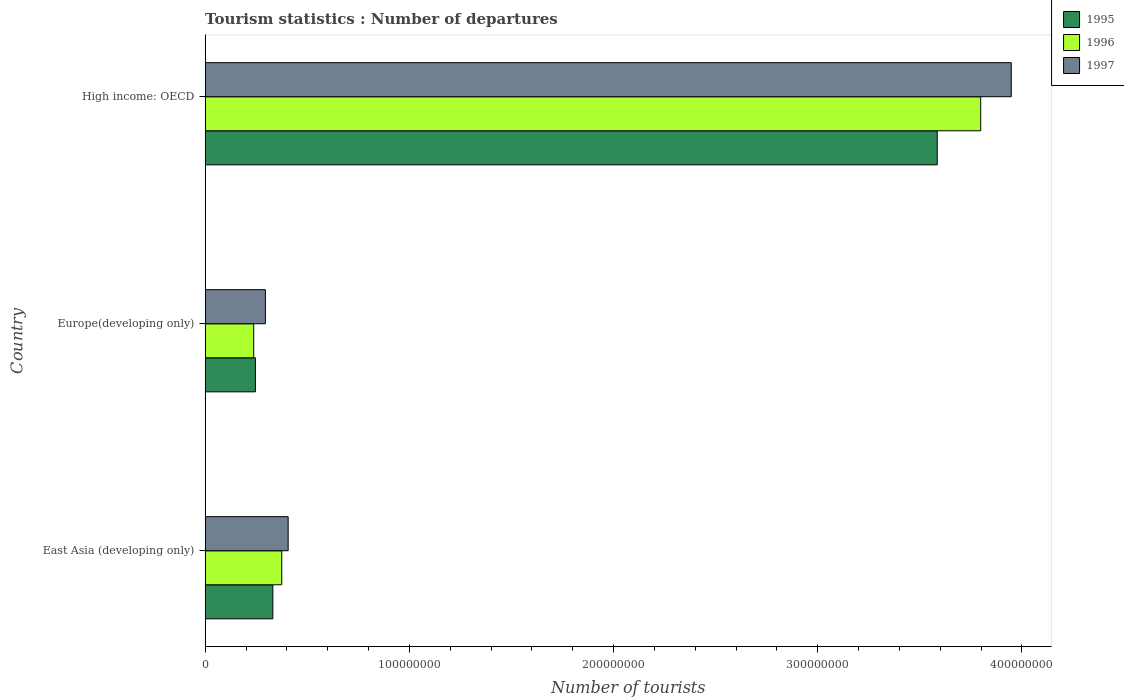How many different coloured bars are there?
Your answer should be compact. 3. Are the number of bars per tick equal to the number of legend labels?
Your answer should be compact. Yes. Are the number of bars on each tick of the Y-axis equal?
Provide a succinct answer. Yes. How many bars are there on the 1st tick from the bottom?
Provide a succinct answer. 3. What is the label of the 2nd group of bars from the top?
Your answer should be very brief. Europe(developing only). What is the number of tourist departures in 1997 in Europe(developing only)?
Your answer should be compact. 2.95e+07. Across all countries, what is the maximum number of tourist departures in 1995?
Make the answer very short. 3.58e+08. Across all countries, what is the minimum number of tourist departures in 1996?
Make the answer very short. 2.38e+07. In which country was the number of tourist departures in 1995 maximum?
Offer a very short reply. High income: OECD. In which country was the number of tourist departures in 1996 minimum?
Offer a very short reply. Europe(developing only). What is the total number of tourist departures in 1997 in the graph?
Provide a succinct answer. 4.65e+08. What is the difference between the number of tourist departures in 1995 in East Asia (developing only) and that in Europe(developing only)?
Provide a succinct answer. 8.52e+06. What is the difference between the number of tourist departures in 1996 in Europe(developing only) and the number of tourist departures in 1997 in East Asia (developing only)?
Keep it short and to the point. -1.69e+07. What is the average number of tourist departures in 1997 per country?
Make the answer very short. 1.55e+08. What is the difference between the number of tourist departures in 1995 and number of tourist departures in 1997 in East Asia (developing only)?
Keep it short and to the point. -7.50e+06. What is the ratio of the number of tourist departures in 1996 in East Asia (developing only) to that in High income: OECD?
Your answer should be compact. 0.1. Is the number of tourist departures in 1995 in Europe(developing only) less than that in High income: OECD?
Your answer should be compact. Yes. Is the difference between the number of tourist departures in 1995 in East Asia (developing only) and Europe(developing only) greater than the difference between the number of tourist departures in 1997 in East Asia (developing only) and Europe(developing only)?
Your answer should be very brief. No. What is the difference between the highest and the second highest number of tourist departures in 1996?
Your answer should be compact. 3.42e+08. What is the difference between the highest and the lowest number of tourist departures in 1997?
Keep it short and to the point. 3.65e+08. In how many countries, is the number of tourist departures in 1996 greater than the average number of tourist departures in 1996 taken over all countries?
Provide a short and direct response. 1. Is the sum of the number of tourist departures in 1995 in East Asia (developing only) and Europe(developing only) greater than the maximum number of tourist departures in 1997 across all countries?
Provide a short and direct response. No. What does the 1st bar from the top in East Asia (developing only) represents?
Keep it short and to the point. 1997. Is it the case that in every country, the sum of the number of tourist departures in 1996 and number of tourist departures in 1997 is greater than the number of tourist departures in 1995?
Give a very brief answer. Yes. How many bars are there?
Your answer should be very brief. 9. How many countries are there in the graph?
Keep it short and to the point. 3. Are the values on the major ticks of X-axis written in scientific E-notation?
Your response must be concise. No. Does the graph contain grids?
Keep it short and to the point. No. Where does the legend appear in the graph?
Your response must be concise. Top right. What is the title of the graph?
Provide a succinct answer. Tourism statistics : Number of departures. What is the label or title of the X-axis?
Provide a short and direct response. Number of tourists. What is the label or title of the Y-axis?
Your answer should be very brief. Country. What is the Number of tourists of 1995 in East Asia (developing only)?
Your response must be concise. 3.31e+07. What is the Number of tourists in 1996 in East Asia (developing only)?
Provide a succinct answer. 3.75e+07. What is the Number of tourists in 1997 in East Asia (developing only)?
Offer a terse response. 4.06e+07. What is the Number of tourists of 1995 in Europe(developing only)?
Your response must be concise. 2.46e+07. What is the Number of tourists in 1996 in Europe(developing only)?
Your answer should be very brief. 2.38e+07. What is the Number of tourists of 1997 in Europe(developing only)?
Provide a succinct answer. 2.95e+07. What is the Number of tourists of 1995 in High income: OECD?
Your response must be concise. 3.58e+08. What is the Number of tourists of 1996 in High income: OECD?
Your response must be concise. 3.80e+08. What is the Number of tourists in 1997 in High income: OECD?
Your response must be concise. 3.95e+08. Across all countries, what is the maximum Number of tourists of 1995?
Provide a short and direct response. 3.58e+08. Across all countries, what is the maximum Number of tourists of 1996?
Make the answer very short. 3.80e+08. Across all countries, what is the maximum Number of tourists in 1997?
Provide a succinct answer. 3.95e+08. Across all countries, what is the minimum Number of tourists of 1995?
Offer a terse response. 2.46e+07. Across all countries, what is the minimum Number of tourists in 1996?
Provide a succinct answer. 2.38e+07. Across all countries, what is the minimum Number of tourists in 1997?
Your response must be concise. 2.95e+07. What is the total Number of tourists of 1995 in the graph?
Make the answer very short. 4.16e+08. What is the total Number of tourists in 1996 in the graph?
Offer a terse response. 4.41e+08. What is the total Number of tourists in 1997 in the graph?
Offer a terse response. 4.65e+08. What is the difference between the Number of tourists in 1995 in East Asia (developing only) and that in Europe(developing only)?
Your answer should be very brief. 8.52e+06. What is the difference between the Number of tourists in 1996 in East Asia (developing only) and that in Europe(developing only)?
Make the answer very short. 1.37e+07. What is the difference between the Number of tourists in 1997 in East Asia (developing only) and that in Europe(developing only)?
Your answer should be very brief. 1.11e+07. What is the difference between the Number of tourists in 1995 in East Asia (developing only) and that in High income: OECD?
Offer a terse response. -3.25e+08. What is the difference between the Number of tourists in 1996 in East Asia (developing only) and that in High income: OECD?
Offer a very short reply. -3.42e+08. What is the difference between the Number of tourists of 1997 in East Asia (developing only) and that in High income: OECD?
Your answer should be compact. -3.54e+08. What is the difference between the Number of tourists in 1995 in Europe(developing only) and that in High income: OECD?
Your answer should be compact. -3.34e+08. What is the difference between the Number of tourists in 1996 in Europe(developing only) and that in High income: OECD?
Your response must be concise. -3.56e+08. What is the difference between the Number of tourists of 1997 in Europe(developing only) and that in High income: OECD?
Your response must be concise. -3.65e+08. What is the difference between the Number of tourists of 1995 in East Asia (developing only) and the Number of tourists of 1996 in Europe(developing only)?
Offer a very short reply. 9.37e+06. What is the difference between the Number of tourists of 1995 in East Asia (developing only) and the Number of tourists of 1997 in Europe(developing only)?
Your answer should be compact. 3.65e+06. What is the difference between the Number of tourists of 1996 in East Asia (developing only) and the Number of tourists of 1997 in Europe(developing only)?
Offer a very short reply. 8.00e+06. What is the difference between the Number of tourists in 1995 in East Asia (developing only) and the Number of tourists in 1996 in High income: OECD?
Provide a succinct answer. -3.47e+08. What is the difference between the Number of tourists of 1995 in East Asia (developing only) and the Number of tourists of 1997 in High income: OECD?
Offer a terse response. -3.62e+08. What is the difference between the Number of tourists in 1996 in East Asia (developing only) and the Number of tourists in 1997 in High income: OECD?
Provide a short and direct response. -3.57e+08. What is the difference between the Number of tourists of 1995 in Europe(developing only) and the Number of tourists of 1996 in High income: OECD?
Give a very brief answer. -3.55e+08. What is the difference between the Number of tourists of 1995 in Europe(developing only) and the Number of tourists of 1997 in High income: OECD?
Keep it short and to the point. -3.70e+08. What is the difference between the Number of tourists in 1996 in Europe(developing only) and the Number of tourists in 1997 in High income: OECD?
Provide a short and direct response. -3.71e+08. What is the average Number of tourists of 1995 per country?
Your answer should be very brief. 1.39e+08. What is the average Number of tourists in 1996 per country?
Your answer should be compact. 1.47e+08. What is the average Number of tourists in 1997 per country?
Provide a short and direct response. 1.55e+08. What is the difference between the Number of tourists in 1995 and Number of tourists in 1996 in East Asia (developing only)?
Your answer should be very brief. -4.35e+06. What is the difference between the Number of tourists in 1995 and Number of tourists in 1997 in East Asia (developing only)?
Keep it short and to the point. -7.50e+06. What is the difference between the Number of tourists in 1996 and Number of tourists in 1997 in East Asia (developing only)?
Make the answer very short. -3.15e+06. What is the difference between the Number of tourists of 1995 and Number of tourists of 1996 in Europe(developing only)?
Give a very brief answer. 8.44e+05. What is the difference between the Number of tourists in 1995 and Number of tourists in 1997 in Europe(developing only)?
Keep it short and to the point. -4.88e+06. What is the difference between the Number of tourists of 1996 and Number of tourists of 1997 in Europe(developing only)?
Keep it short and to the point. -5.72e+06. What is the difference between the Number of tourists in 1995 and Number of tourists in 1996 in High income: OECD?
Ensure brevity in your answer.  -2.13e+07. What is the difference between the Number of tourists of 1995 and Number of tourists of 1997 in High income: OECD?
Provide a short and direct response. -3.63e+07. What is the difference between the Number of tourists of 1996 and Number of tourists of 1997 in High income: OECD?
Your answer should be very brief. -1.50e+07. What is the ratio of the Number of tourists of 1995 in East Asia (developing only) to that in Europe(developing only)?
Give a very brief answer. 1.35. What is the ratio of the Number of tourists in 1996 in East Asia (developing only) to that in Europe(developing only)?
Make the answer very short. 1.58. What is the ratio of the Number of tourists of 1997 in East Asia (developing only) to that in Europe(developing only)?
Your response must be concise. 1.38. What is the ratio of the Number of tourists in 1995 in East Asia (developing only) to that in High income: OECD?
Your answer should be compact. 0.09. What is the ratio of the Number of tourists of 1996 in East Asia (developing only) to that in High income: OECD?
Your answer should be very brief. 0.1. What is the ratio of the Number of tourists of 1997 in East Asia (developing only) to that in High income: OECD?
Provide a short and direct response. 0.1. What is the ratio of the Number of tourists in 1995 in Europe(developing only) to that in High income: OECD?
Offer a very short reply. 0.07. What is the ratio of the Number of tourists of 1996 in Europe(developing only) to that in High income: OECD?
Offer a very short reply. 0.06. What is the ratio of the Number of tourists of 1997 in Europe(developing only) to that in High income: OECD?
Your answer should be compact. 0.07. What is the difference between the highest and the second highest Number of tourists in 1995?
Make the answer very short. 3.25e+08. What is the difference between the highest and the second highest Number of tourists of 1996?
Give a very brief answer. 3.42e+08. What is the difference between the highest and the second highest Number of tourists of 1997?
Your answer should be compact. 3.54e+08. What is the difference between the highest and the lowest Number of tourists in 1995?
Offer a very short reply. 3.34e+08. What is the difference between the highest and the lowest Number of tourists of 1996?
Make the answer very short. 3.56e+08. What is the difference between the highest and the lowest Number of tourists of 1997?
Offer a terse response. 3.65e+08. 